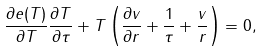Convert formula to latex. <formula><loc_0><loc_0><loc_500><loc_500>\frac { \partial e ( T ) } { \partial T } \frac { \partial T } { \partial \tau } + T \left ( \frac { \partial v } { \partial r } + \frac { 1 } { \tau } + \frac { v } { r } \right ) = 0 ,</formula> 